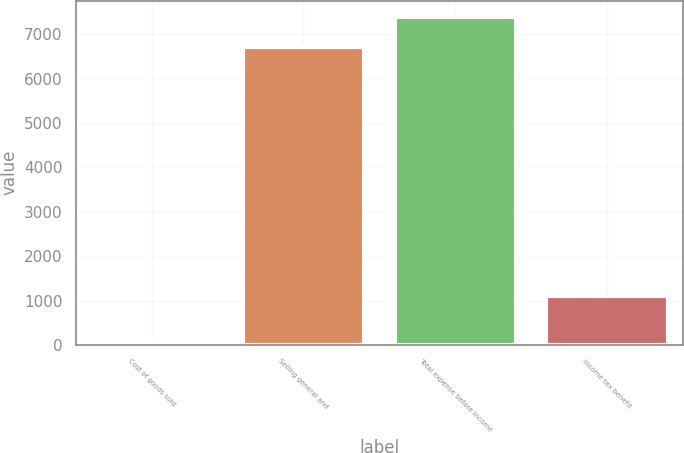Convert chart. <chart><loc_0><loc_0><loc_500><loc_500><bar_chart><fcel>Cost of goods sold<fcel>Selling general and<fcel>Total expense before income<fcel>Income tax benefit<nl><fcel>79<fcel>6717<fcel>7388.7<fcel>1108<nl></chart> 